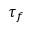Convert formula to latex. <formula><loc_0><loc_0><loc_500><loc_500>\tau _ { f }</formula> 